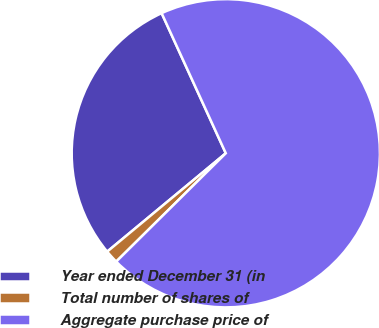Convert chart. <chart><loc_0><loc_0><loc_500><loc_500><pie_chart><fcel>Year ended December 31 (in<fcel>Total number of shares of<fcel>Aggregate purchase price of<nl><fcel>29.18%<fcel>1.39%<fcel>69.42%<nl></chart> 